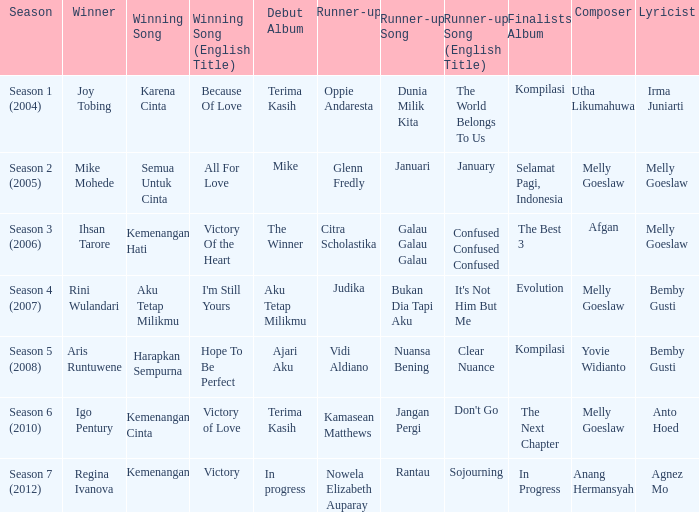Which album debuted in season 2 (2005)? Mike. 